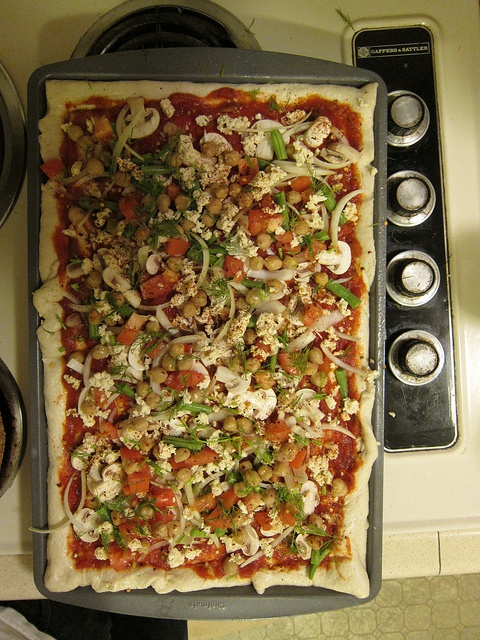Describe the objects in this image and their specific colors. I can see oven in black, olive, tan, maroon, and khaki tones and pizza in olive, maroon, and tan tones in this image. 